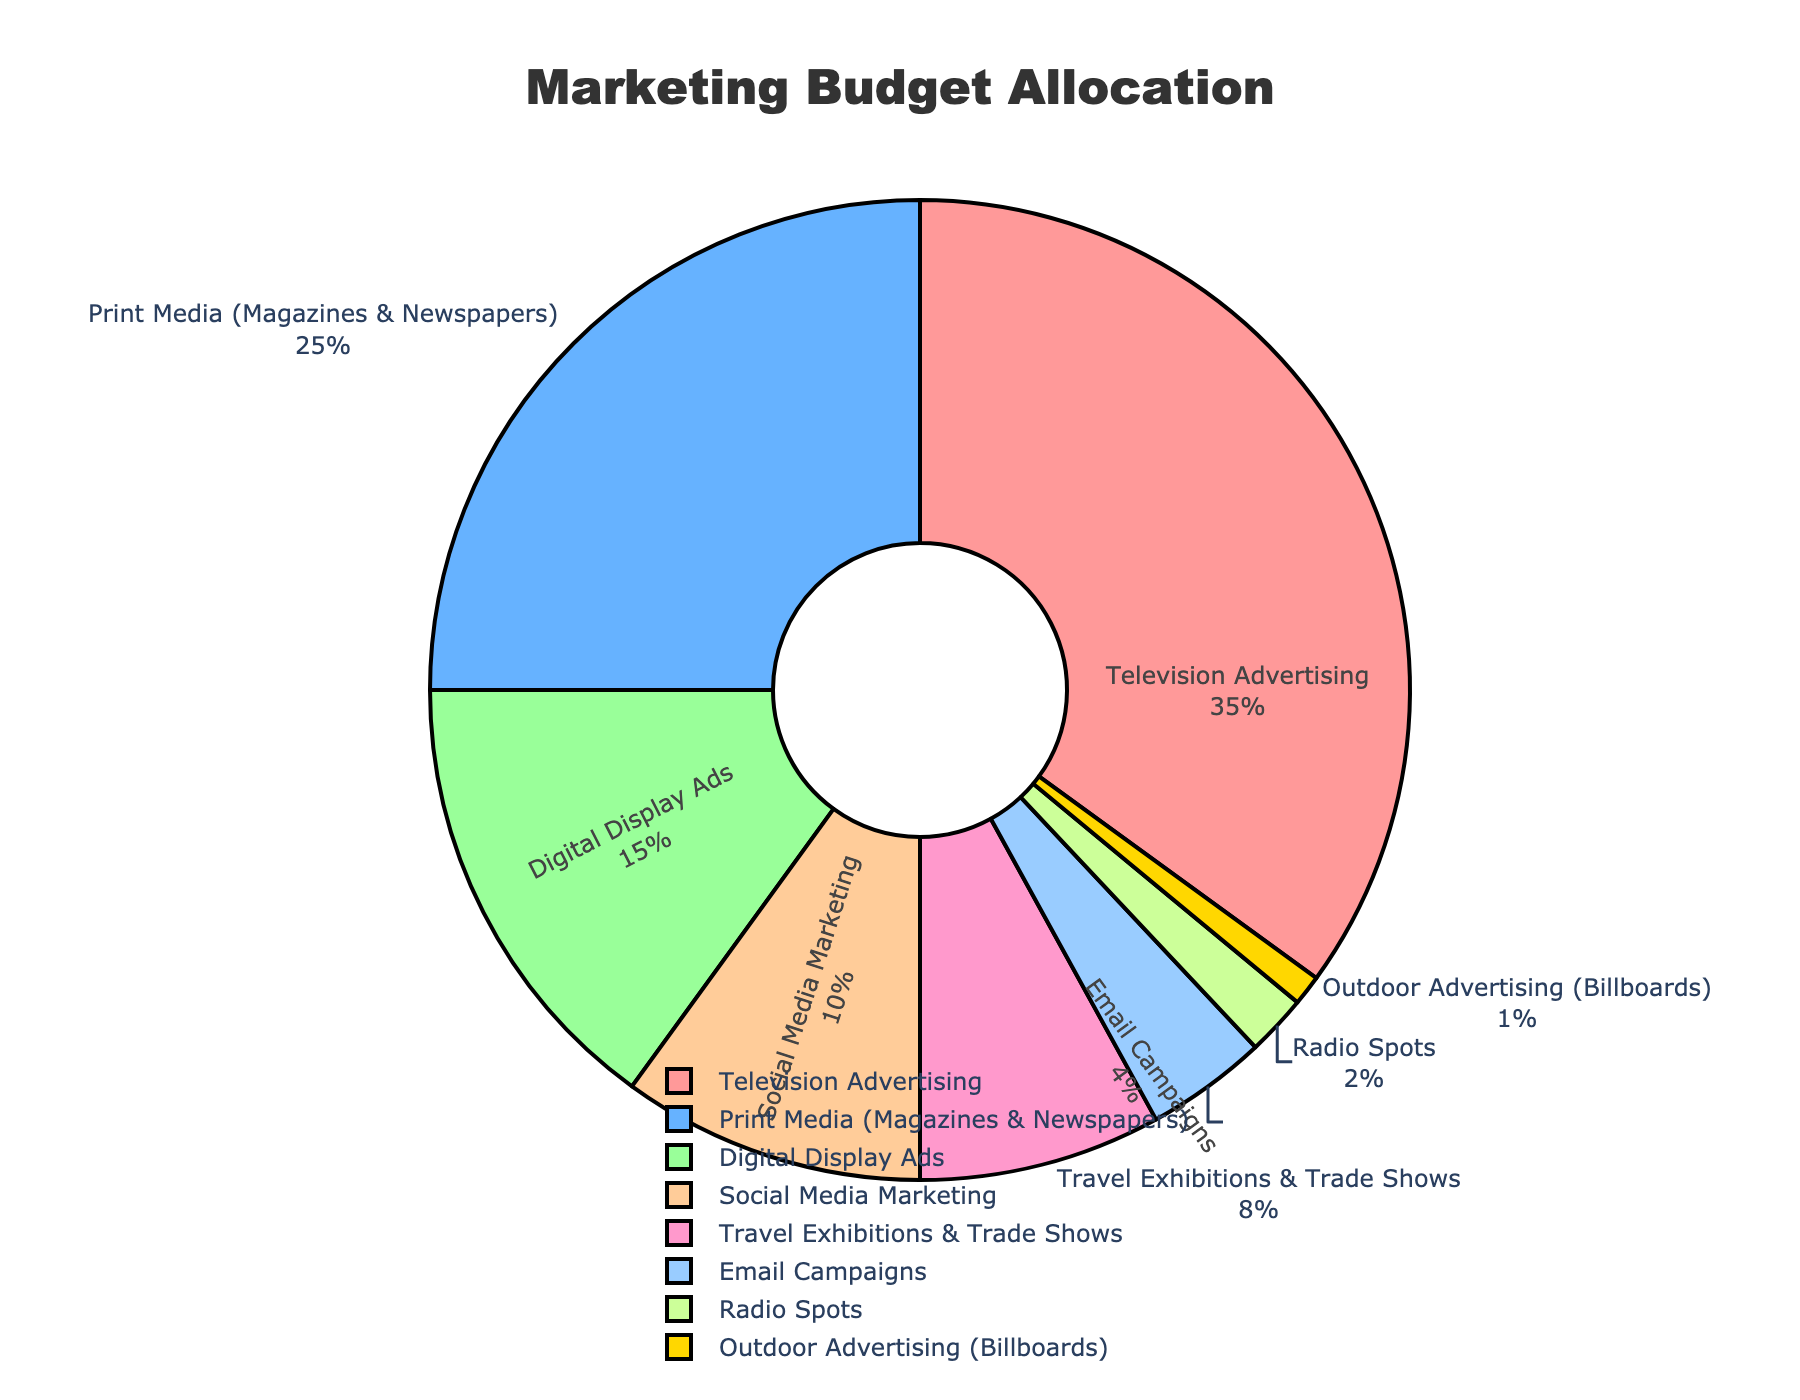What's the largest portion of the marketing budget allocated to? The largest segment of the pie chart is the one for Television Advertising, which occupies the biggest visual space. This is denoted by both the largest size and the percentage label at 35%.
Answer: Television Advertising What is the combined percentage of budget allocated to both Social Media Marketing and Email Campaigns? To find the combined percentage, add the percentages for Social Media Marketing (10%) and Email Campaigns (4%). So, \(10 + 4 = 14\)%.
Answer: 14% Which promotional channel receives a smaller budget, Print Media or Digital Display Ads? By comparing the displayed percentages, Print Media receives 25% while Digital Display Ads receives 15%. Thus, Digital Display Ads receives a smaller budget.
Answer: Digital Display Ads By how much does the proportion of budget allocated to Radio Spots exceed that of Outdoor Advertising? Subtract the percentage for Outdoor Advertising (1%) from Radio Spots (2%). So, \(2 - 1 = 1\)%.
Answer: 1% What is the total percentage of the budget allocated to Travel Exhibitions & Trade Shows, Email Campaigns, and Radio Spots? To find this, add the percentages for Travel Exhibitions & Trade Shows (8%), Email Campaigns (4%), and Radio Spots (2%). So, \(8 + 4 + 2 = 14\)%.
Answer: 14% What fraction of the marketing budget is allocated to all digital channels combined? Add the percentages for Digital Display Ads (15%), Social Media Marketing (10%), and Email Campaigns (4%). So, \(15 + 10 + 4 = 29\)%. Then, convert this percentage to a fraction: \(29/100\).
Answer: 29/100 If we combined the budget for Radio Spots and Outdoor Advertising into a single category, how would it compare to the budget for Email Campaigns? Combined Radio Spots (2%) and Outdoor Advertising (1%) yield \(2 + 1 = 3\)%. This combined figure (3%) is less than the budget for Email Campaigns (4%).
Answer: Email Campaigns Which color is used to represent the segment with the smallest budget allocation? The smallest budget allocation is Outdoor Advertising (1%), and this segment is visually represented by the yellow color.
Answer: Yellow 